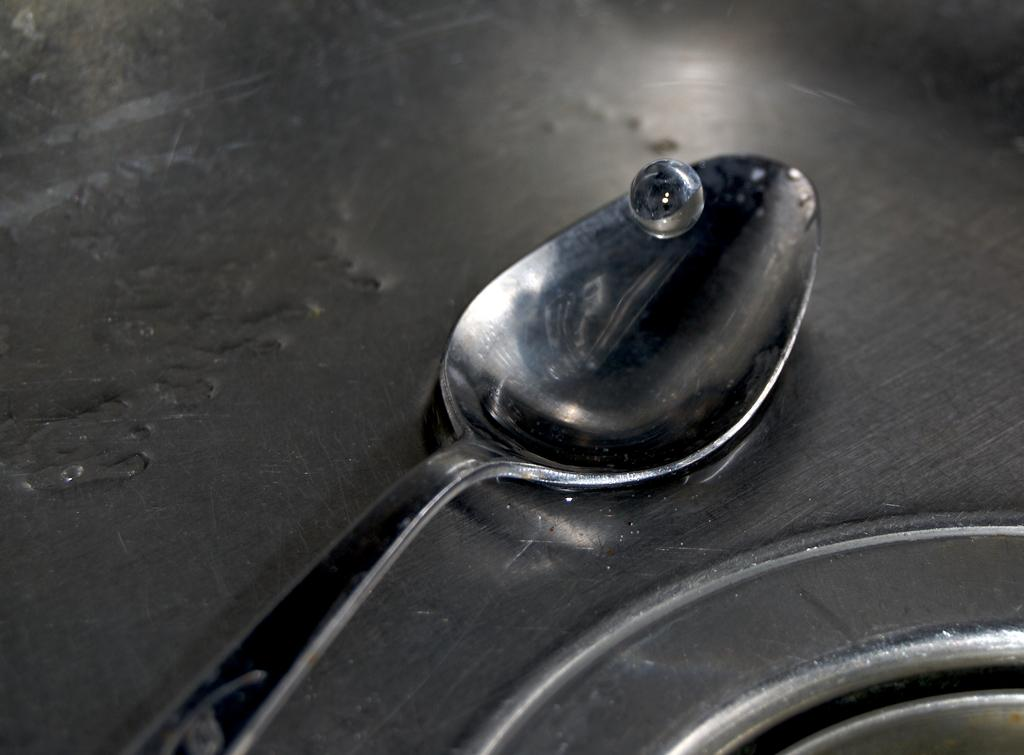What object can be seen in the picture? There is a spoon in the picture. What is on the spoon? The spoon has water on it. On what surface is the spoon placed? The spoon is placed on a steel surface. How many visitors can be seen entering through the gate in the image? There are no visitors or gates present in the image; it only features a spoon with water on it placed on a steel surface. 